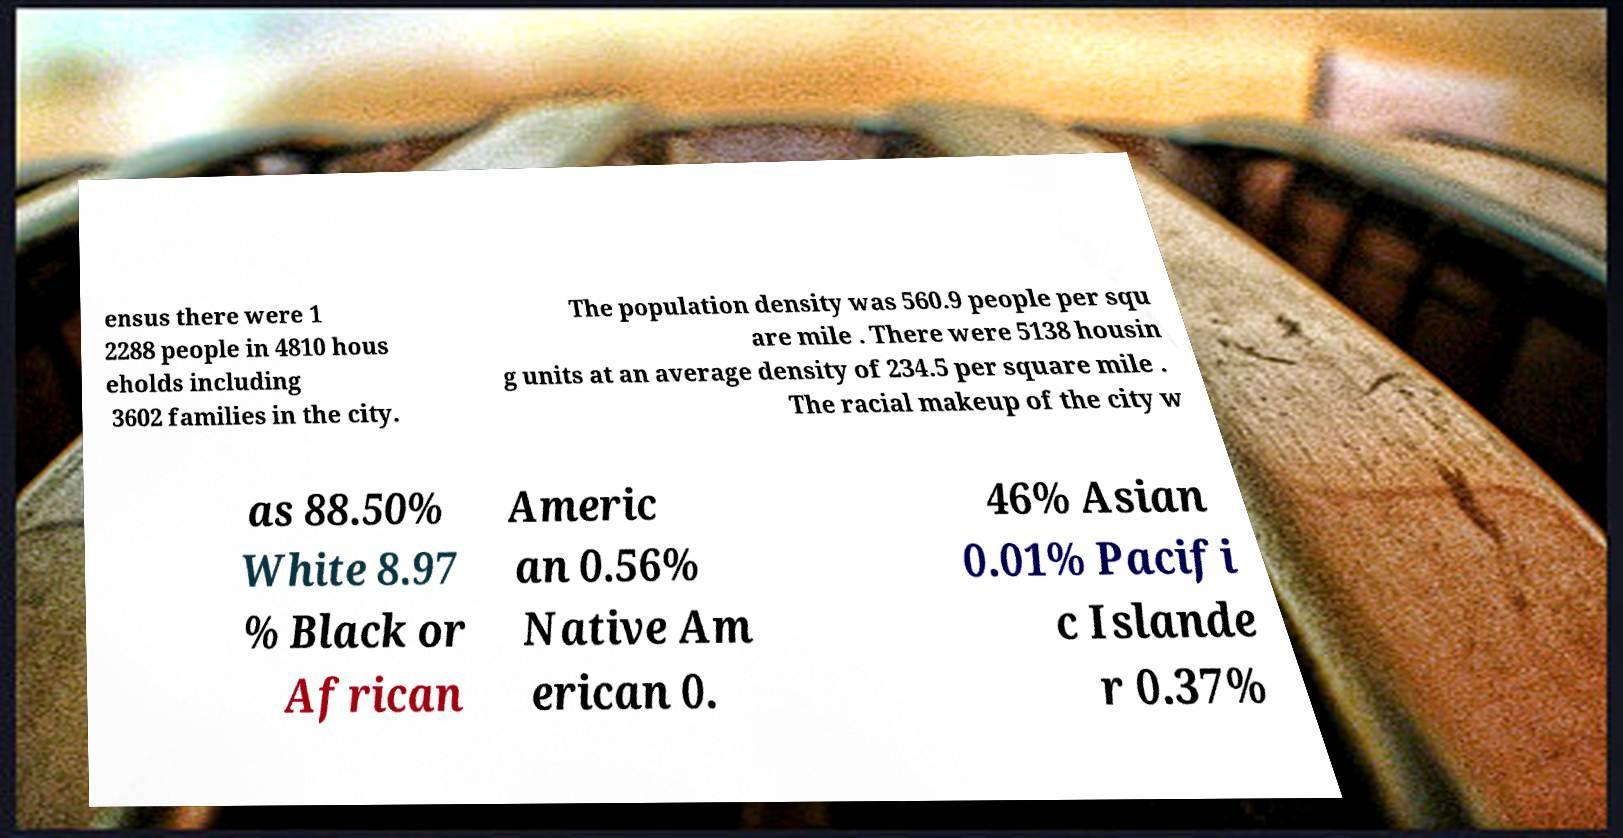Can you accurately transcribe the text from the provided image for me? ensus there were 1 2288 people in 4810 hous eholds including 3602 families in the city. The population density was 560.9 people per squ are mile . There were 5138 housin g units at an average density of 234.5 per square mile . The racial makeup of the city w as 88.50% White 8.97 % Black or African Americ an 0.56% Native Am erican 0. 46% Asian 0.01% Pacifi c Islande r 0.37% 